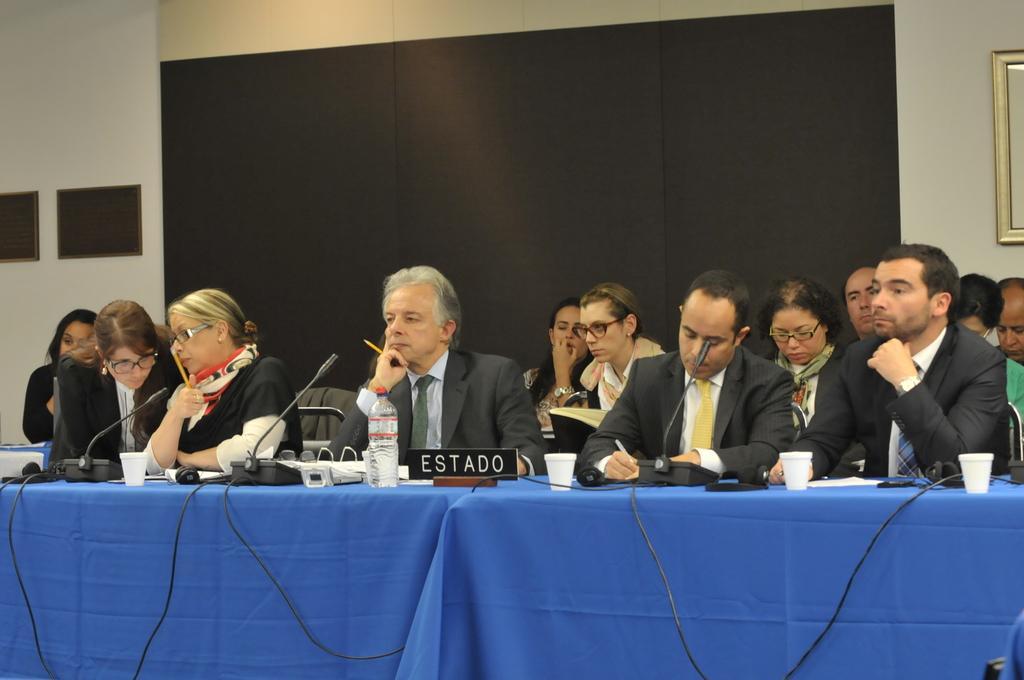How would you summarize this image in a sentence or two? In this image I can see number of people are sitting. I can also see most of them are wearing formal dresses and few of them are wearing specs. Here I can see a table and on it I can see blue colour table cloth, few wires, few mics, few white colour glasses, a black colour thing and on it I can see something is written. I can also see a frame on this wall. 